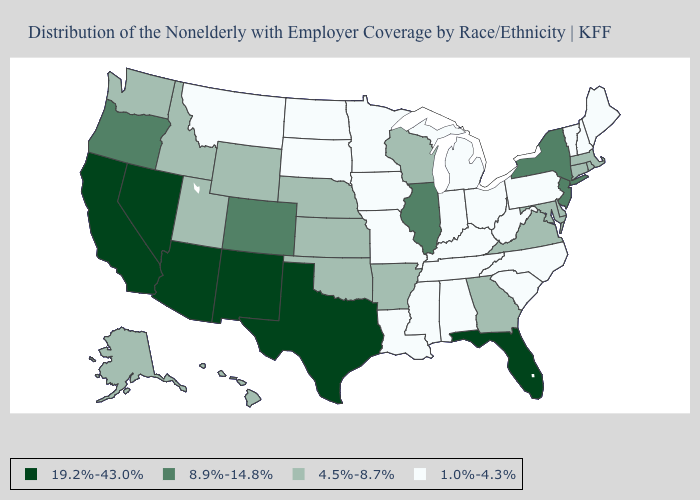How many symbols are there in the legend?
Quick response, please. 4. Among the states that border Kansas , does Nebraska have the highest value?
Write a very short answer. No. Is the legend a continuous bar?
Quick response, please. No. What is the lowest value in the USA?
Answer briefly. 1.0%-4.3%. Does the first symbol in the legend represent the smallest category?
Quick response, please. No. What is the value of Massachusetts?
Write a very short answer. 4.5%-8.7%. Name the states that have a value in the range 1.0%-4.3%?
Quick response, please. Alabama, Indiana, Iowa, Kentucky, Louisiana, Maine, Michigan, Minnesota, Mississippi, Missouri, Montana, New Hampshire, North Carolina, North Dakota, Ohio, Pennsylvania, South Carolina, South Dakota, Tennessee, Vermont, West Virginia. Among the states that border Tennessee , which have the lowest value?
Keep it brief. Alabama, Kentucky, Mississippi, Missouri, North Carolina. Name the states that have a value in the range 8.9%-14.8%?
Write a very short answer. Colorado, Illinois, New Jersey, New York, Oregon. Does South Dakota have a lower value than Iowa?
Concise answer only. No. Which states have the lowest value in the MidWest?
Write a very short answer. Indiana, Iowa, Michigan, Minnesota, Missouri, North Dakota, Ohio, South Dakota. Among the states that border Colorado , which have the highest value?
Be succinct. Arizona, New Mexico. Which states have the lowest value in the South?
Give a very brief answer. Alabama, Kentucky, Louisiana, Mississippi, North Carolina, South Carolina, Tennessee, West Virginia. Among the states that border California , does Oregon have the lowest value?
Answer briefly. Yes. 